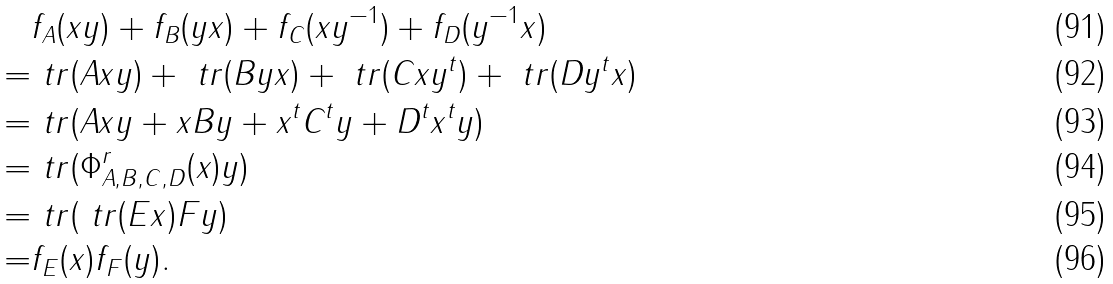<formula> <loc_0><loc_0><loc_500><loc_500>& f _ { A } ( x y ) + f _ { B } ( y x ) + f _ { C } ( x y ^ { - 1 } ) + f _ { D } ( y ^ { - 1 } x ) \\ = & \ t r ( A x y ) + \ t r ( B y x ) + \ t r ( C x y ^ { t } ) + \ t r ( D y ^ { t } x ) \\ = & \ t r ( A x y + x B y + x ^ { t } C ^ { t } y + D ^ { t } x ^ { t } y ) \\ = & \ t r ( \Phi ^ { r } _ { A , B , C , D } ( x ) y ) \\ = & \ t r ( \ t r ( E x ) F y ) \\ = & f _ { E } ( x ) f _ { F } ( y ) .</formula> 